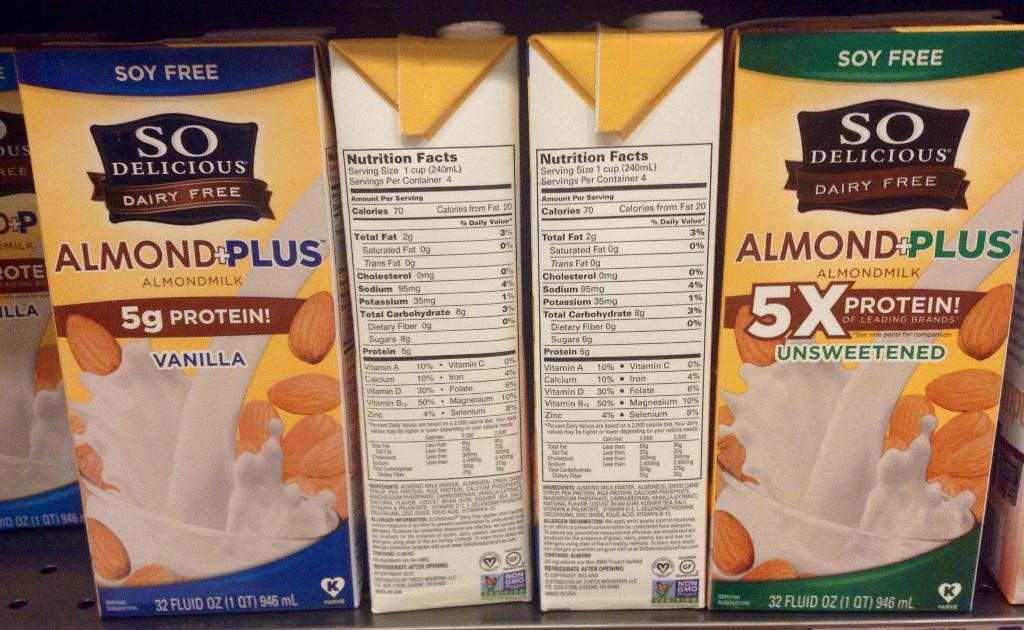What type of containers are visible in the image? There are paper almond milk containers in the image. Where are the containers located? The containers are on a rack. How many bikes are parked on the roof in the image? There are no bikes or roof present in the image; it only features paper almond milk containers on a rack. 